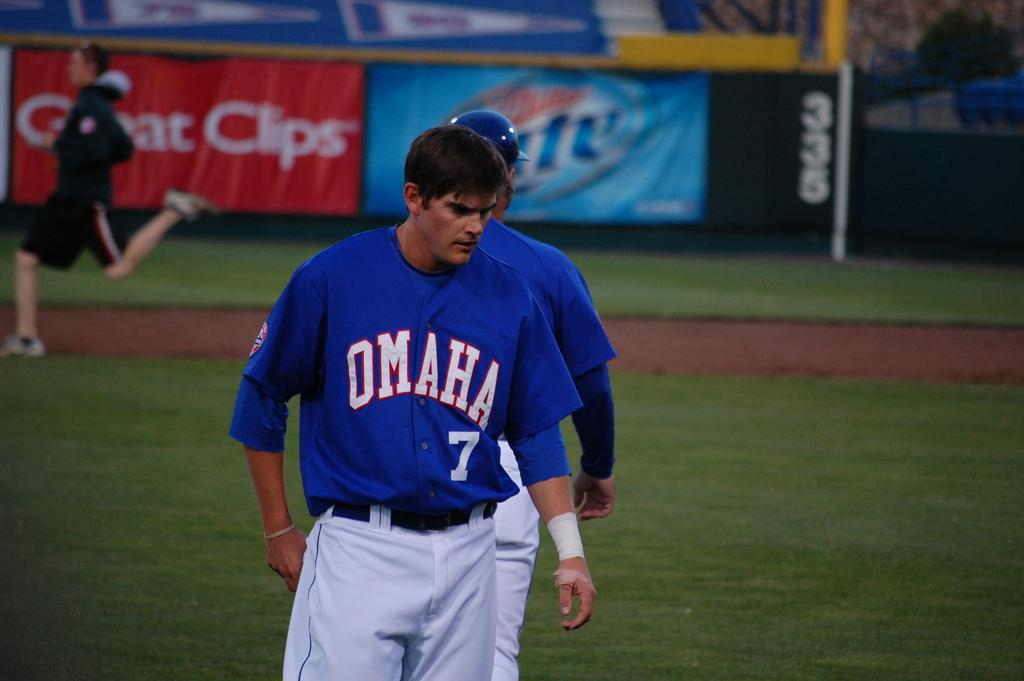<image>
Share a concise interpretation of the image provided. a baseball player with omaha jersey number 7 